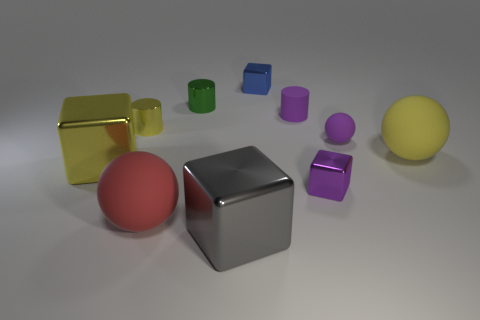Subtract 1 cylinders. How many cylinders are left? 2 Subtract all cyan cubes. Subtract all green cylinders. How many cubes are left? 4 Subtract all cylinders. How many objects are left? 7 Add 6 purple cylinders. How many purple cylinders are left? 7 Add 4 big gray blocks. How many big gray blocks exist? 5 Subtract 0 brown cylinders. How many objects are left? 10 Subtract all red objects. Subtract all small yellow metallic cylinders. How many objects are left? 8 